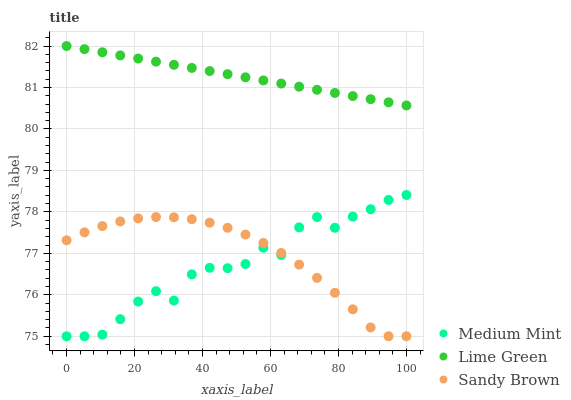Does Medium Mint have the minimum area under the curve?
Answer yes or no. Yes. Does Lime Green have the maximum area under the curve?
Answer yes or no. Yes. Does Sandy Brown have the minimum area under the curve?
Answer yes or no. No. Does Sandy Brown have the maximum area under the curve?
Answer yes or no. No. Is Lime Green the smoothest?
Answer yes or no. Yes. Is Medium Mint the roughest?
Answer yes or no. Yes. Is Sandy Brown the smoothest?
Answer yes or no. No. Is Sandy Brown the roughest?
Answer yes or no. No. Does Medium Mint have the lowest value?
Answer yes or no. Yes. Does Lime Green have the lowest value?
Answer yes or no. No. Does Lime Green have the highest value?
Answer yes or no. Yes. Does Sandy Brown have the highest value?
Answer yes or no. No. Is Medium Mint less than Lime Green?
Answer yes or no. Yes. Is Lime Green greater than Sandy Brown?
Answer yes or no. Yes. Does Sandy Brown intersect Medium Mint?
Answer yes or no. Yes. Is Sandy Brown less than Medium Mint?
Answer yes or no. No. Is Sandy Brown greater than Medium Mint?
Answer yes or no. No. Does Medium Mint intersect Lime Green?
Answer yes or no. No. 